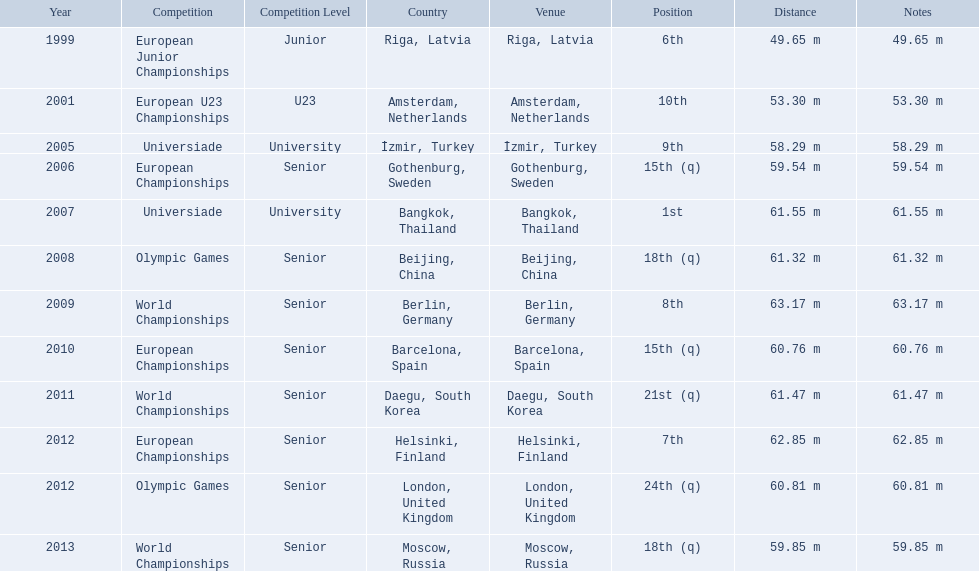What are all the competitions? European Junior Championships, European U23 Championships, Universiade, European Championships, Universiade, Olympic Games, World Championships, European Championships, World Championships, European Championships, Olympic Games, World Championships. What years did they place in the top 10? 1999, 2001, 2005, 2007, 2009, 2012. Besides when they placed first, which position was their highest? 6th. 